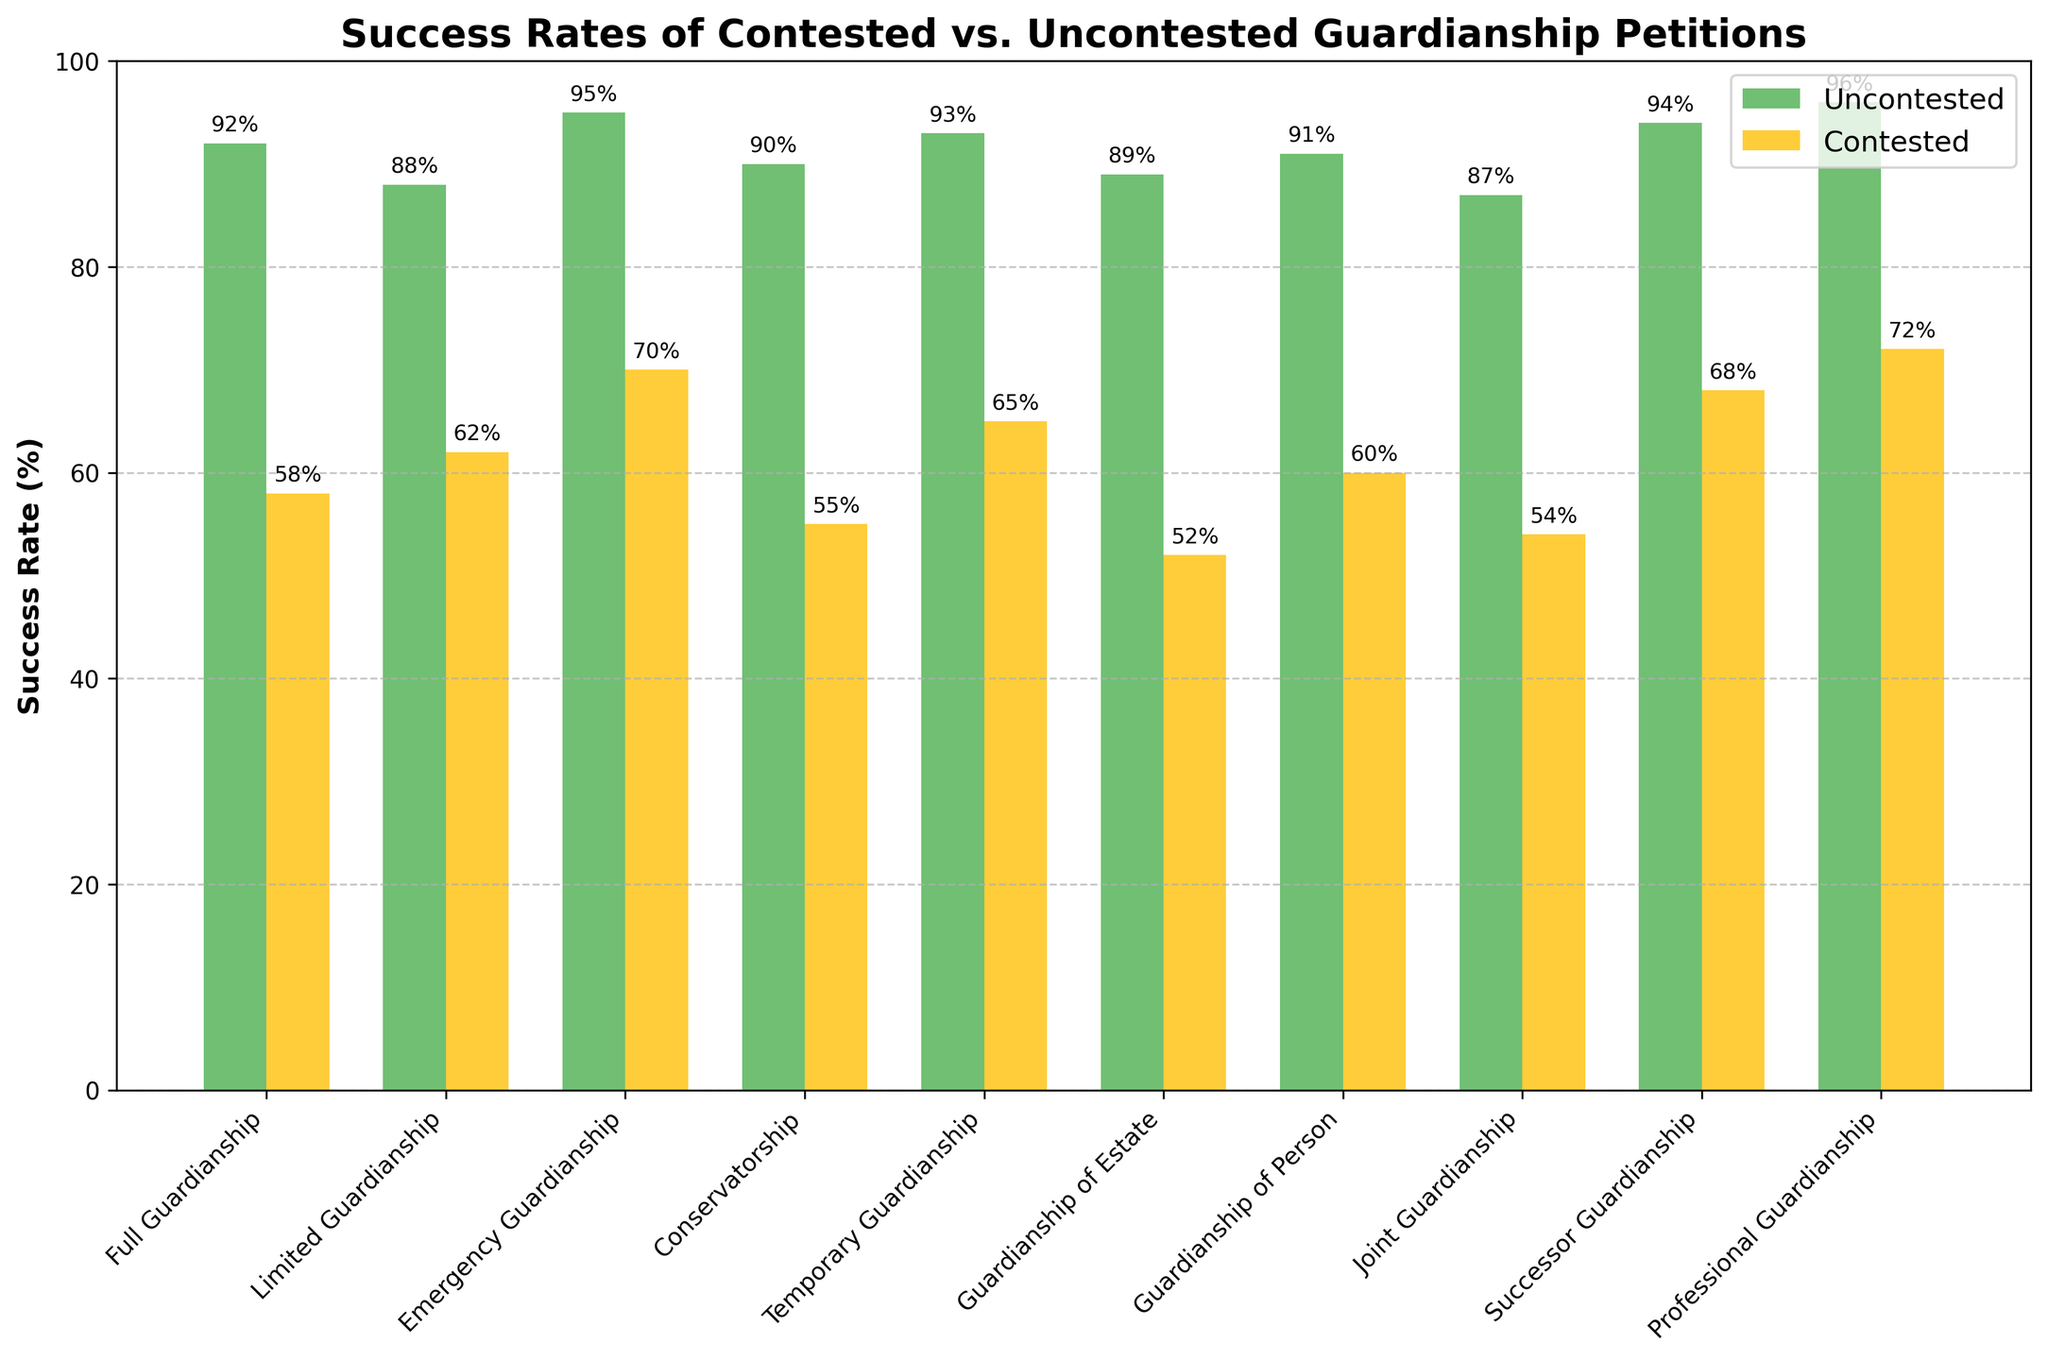How much higher is the success rate of uncontested Emergency Guardianship compared to contested Emergency Guardianship? The uncontested success rate for Emergency Guardianship is 95%, while the contested success rate is 70%. The difference is 95% - 70%.
Answer: 25% Which type of guardianship has the smallest difference in success rates between uncontested and contested petitions? From the data, the smallest difference is found by comparing the success rates of each guardianship type. Limited Guardianship has 88% uncontested success rate and 62% contested success rate. The difference is 88% - 62%, which is 26%. This is the smallest difference.
Answer: Limited Guardianship What's the average success rate for uncontested guardianship petitions? To find the average, add up all the success rates for uncontested petitions and divide by the number of types. The calculation is (92 + 88 + 95 + 90 + 93 + 89 + 91 + 87 + 94 + 96) / 10 = 91.5%.
Answer: 91.5% In which type of guardianship is the success rate of contested petitions greater than or equal to 60% but less than 70%? From the chart, we see that the success rate for contested petitions in Guardianship of Person is 60% and in Emergency Guardianship is 70%. The type that meets the criteria is Guardianship of Person.
Answer: Guardianship of Person Which type of guardianship petitions has the highest success rate for uncontested petitions? The chart shows that Professional Guardianship has a 96% success rate, which is the highest among uncontested petitions.
Answer: Professional Guardianship What is the median success rate of contested guardianship petitions? To find the median, first list the success rates in ascending order: 52, 54, 55, 58, 60, 62, 65, 68, 70, 72. The median is the average of the 5th and 6th values: (60 + 62) / 2 = 61%.
Answer: 61% Is the success rate of contested Conservatorship higher or lower than the success rate of contested Joint Guardianship? The success rate of contested Conservatorship is 55%, and for contested Joint Guardianship, it is 54%. So, it is higher.
Answer: Higher What is the total success rate of uncontested and contested Full Guardianship petitions? The total is found by adding both success rates together: 92% (uncontested) + 58% (contested) = 150%.
Answer: 150% How much lower is the success rate of contested Guardianship of Estate compared to contested Professional Guardianship? The contested success rate for Guardianship of Estate is 52%, and for Professional Guardianship, it is 72%. The difference is 72% - 52%.
Answer: 20% Which type has a more significant difference between uncontested and contested success rates: Conservatorship or Temporary Guardianship? The difference for Conservatorship is 90% - 55% = 35%. The difference for Temporary Guardianship is 93% - 65% = 28%. Conservatorship has a more significant difference.
Answer: Conservatorship 